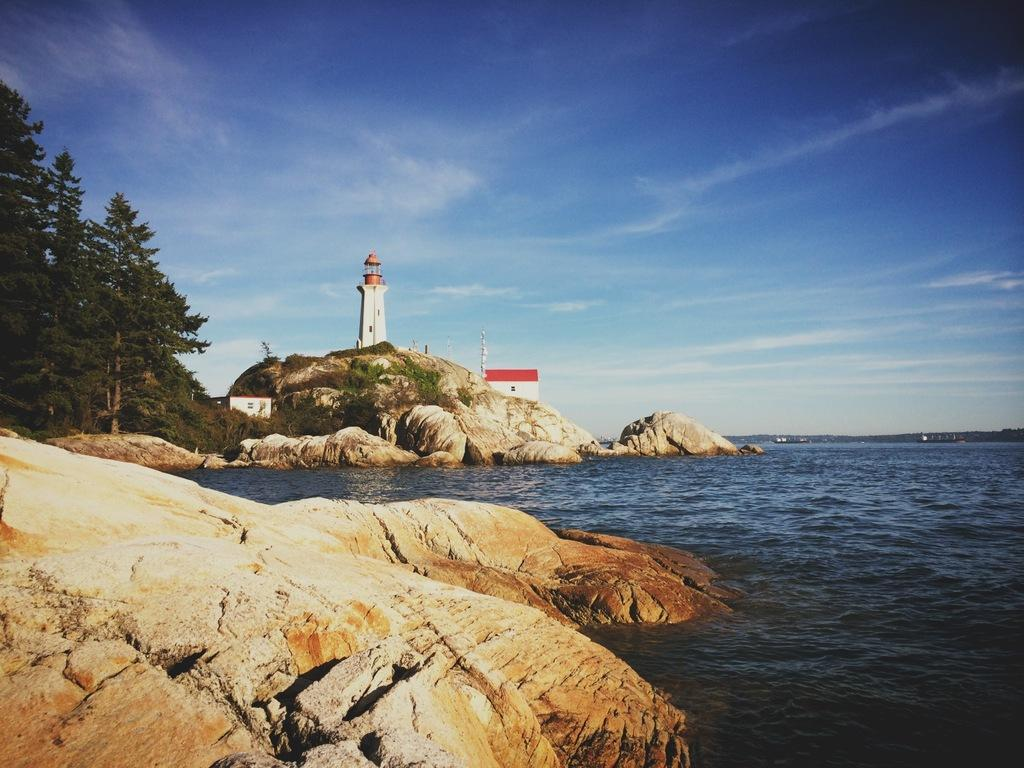What is located at the bottom of the image? There is a river and rocks at the bottom of the image. What can be seen in the background of the image? There are rocks, trees, a tower, a flag, and poles in the background of the image. What is visible at the top of the image? The sky is visible at the top of the image. What type of transport can be seen in the image? There is no transport visible in the image. What color is the tin on the rocks in the image? There is no tin present in the image. 